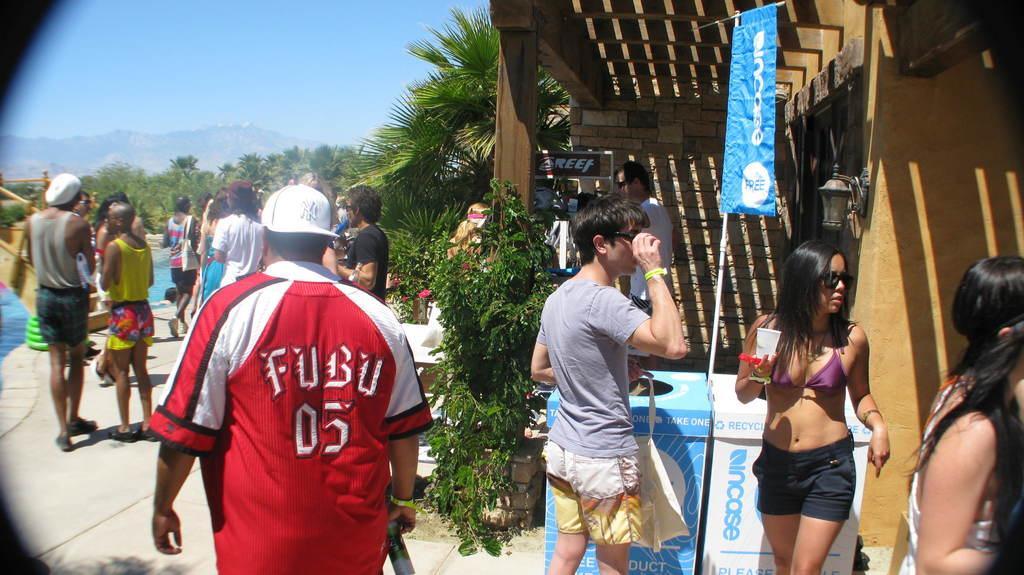Could you give a brief overview of what you see in this image? In this image we can see the people, banner, board, light, plants, pool, trees and also the path. We can also see the roof for shelter. We can see the walls, hills and also the sky. We can see the trash bins. 